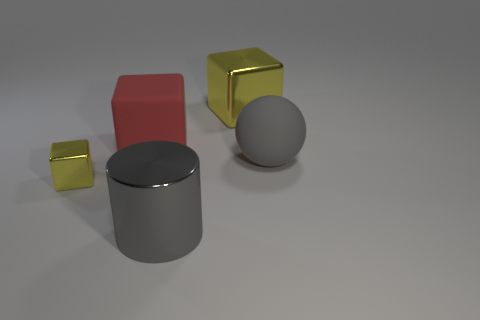Are the shapes in any specific arrangement that suggests a pattern or purpose? The shapes are arranged in a line with varying distances between them, each shape with a clearly defined shadow indicating a common light source. There is no apparent pattern or purpose that suggests a specific functionality, as they seem to be randomly placed for illustrative purposes.  Could the positioning of these objects be relevant for a study of light and shadows? Absolutely, the positioning of the objects with a single light source could very well be part of a study on how different materials and shapes cast shadows, including the direction, length, and softness of the shadows in relation to the objects. 